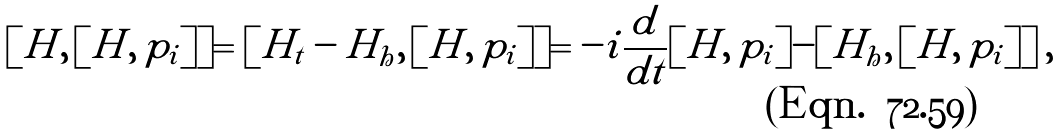Convert formula to latex. <formula><loc_0><loc_0><loc_500><loc_500>[ H , \, [ H , \, p _ { i } ] ] = [ H _ { t } - H _ { h } , \, [ H , \, p _ { i } ] ] = - i \frac { d } { d t } [ H , \, p _ { i } ] - [ H _ { h } , \, [ H , \, p _ { i } ] ] \, ,</formula> 